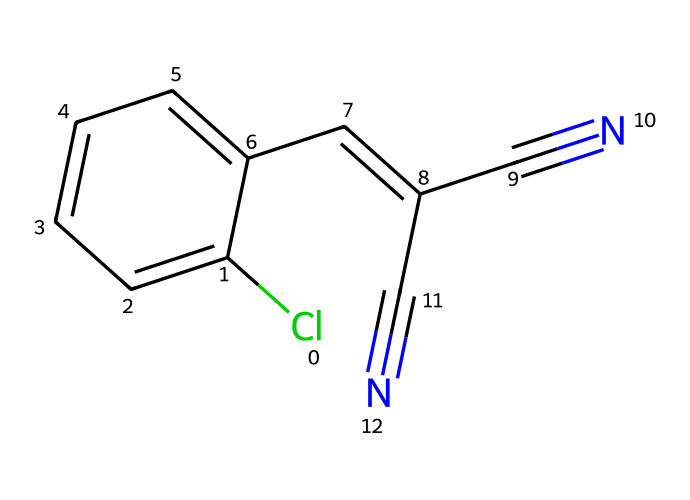What is the main functional group in this chemical? The presence of the cyanide groups (C#N) indicates that the main functional group is nitrile.
Answer: nitrile How many double bonds are present in the structure? Counting the double bonds in the structure, there are two double bonds (one in the aromatic ring and one in the side chain).
Answer: 2 What type of chemical is this compound primarily considered? This compound is primarily considered a gas, specifically a lachrymatory agent, which is often used in tear gas.
Answer: lachrymatory agent How many rings are present in the chemical structure? The structure contains one aromatic ring, which can be identified by the cyclic arrangement of carbon atoms with alternating double bonds.
Answer: 1 What is the total number of carbon atoms in this compound? By counting the carbon atoms in the SMILES representation, there are 9 carbon atoms in total.
Answer: 9 Which atoms are likely responsible for the irritant properties of this compound? The presence of the nitrogen in conjunction with the cyanide functional groups (C#N) is associated with irritant properties.
Answer: nitrogen and cyanide groups What is the significance of the chlorine atom in the structure? The chlorine atom (Cl) contributes to the chemical's overall reactivity and its potential to cause irritation upon exposure.
Answer: reactivity and irritation 